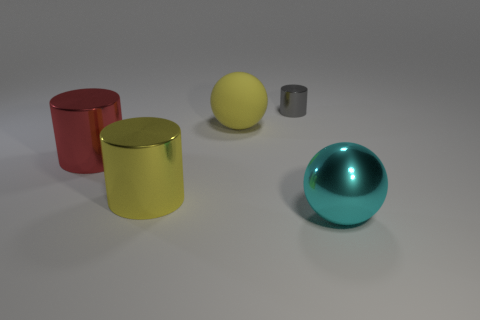Are there any other things that are made of the same material as the cyan object?
Your answer should be compact. Yes. What is the shape of the cyan object that is made of the same material as the tiny gray cylinder?
Offer a very short reply. Sphere. What number of large things are either red metallic things or green shiny cylinders?
Your answer should be compact. 1. There is a sphere that is on the left side of the large cyan metallic ball; are there any large yellow objects that are in front of it?
Offer a terse response. Yes. Are any big cylinders visible?
Your answer should be compact. Yes. There is a large ball right of the sphere that is on the left side of the tiny gray metal thing; what color is it?
Provide a succinct answer. Cyan. There is a large yellow thing that is the same shape as the tiny gray object; what is its material?
Make the answer very short. Metal. What number of objects have the same size as the cyan metal ball?
Provide a succinct answer. 3. What size is the gray cylinder that is made of the same material as the big cyan thing?
Give a very brief answer. Small. What number of big yellow rubber objects have the same shape as the cyan metallic object?
Provide a succinct answer. 1. 